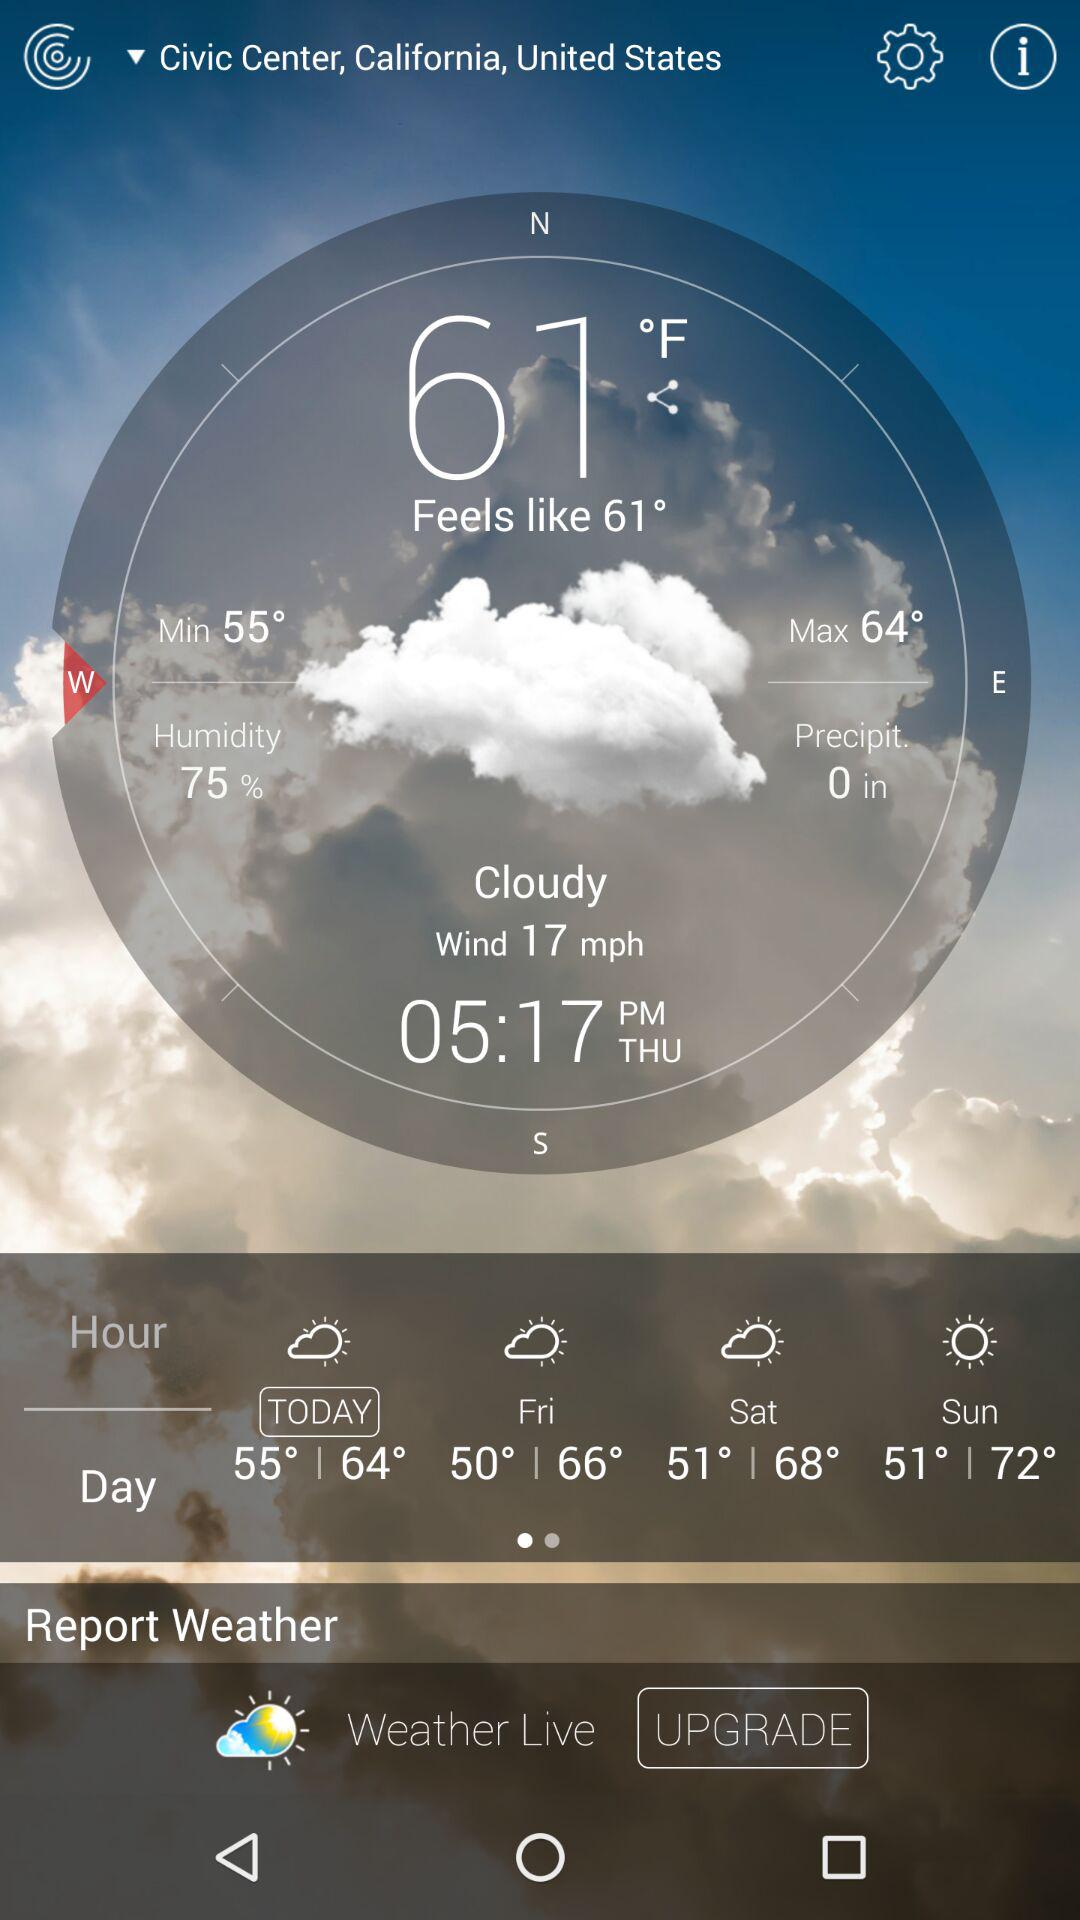What is the percentage of humidity?
Answer the question using a single word or phrase. 75% 